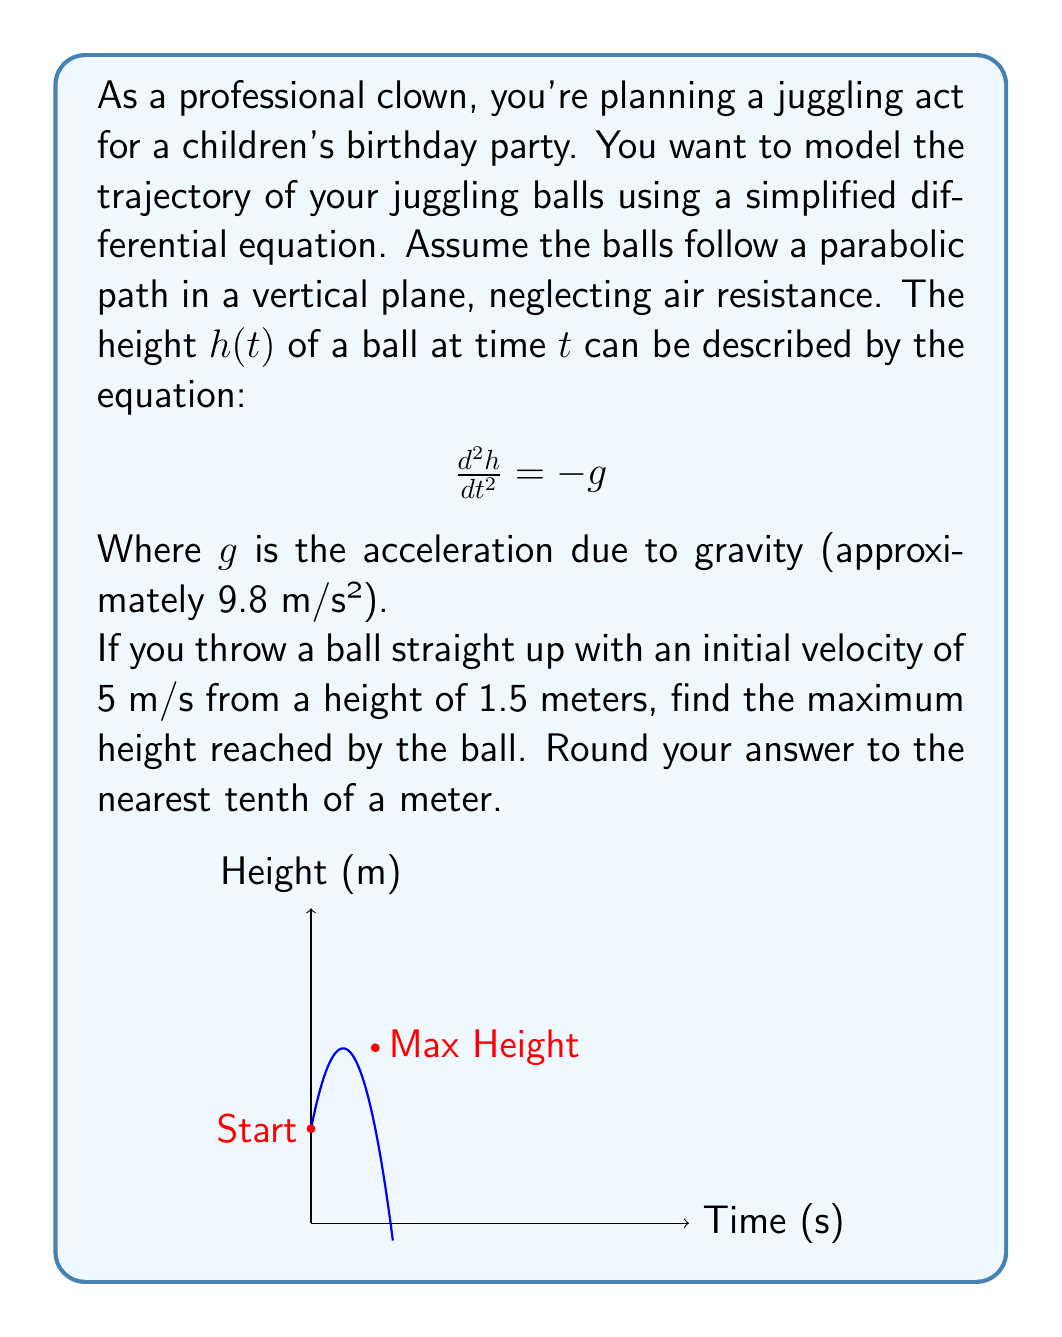Provide a solution to this math problem. Let's approach this step-by-step:

1) The differential equation $\frac{d^2h}{dt^2} = -g$ can be solved by integrating twice:

   $$\frac{dh}{dt} = -gt + v_0$$
   $$h(t) = -\frac{1}{2}gt^2 + v_0t + h_0$$

   Where $v_0$ is the initial velocity and $h_0$ is the initial height.

2) We're given:
   $g = 9.8$ m/s²
   $v_0 = 5$ m/s
   $h_0 = 1.5$ m

3) Substituting these values:

   $$h(t) = -4.9t^2 + 5t + 1.5$$

4) To find the maximum height, we need to find where $\frac{dh}{dt} = 0$:

   $$\frac{dh}{dt} = -9.8t + 5 = 0$$
   $$t = \frac{5}{9.8} \approx 0.51 \text{ seconds}$$

5) Now, let's substitute this time back into our height equation:

   $$h(0.51) = -4.9(0.51)^2 + 5(0.51) + 1.5$$
   $$\approx -1.27 + 2.55 + 1.5$$
   $$\approx 2.78 \text{ meters}$$

6) Rounding to the nearest tenth:

   Maximum height ≈ 2.8 meters
Answer: 2.8 m 